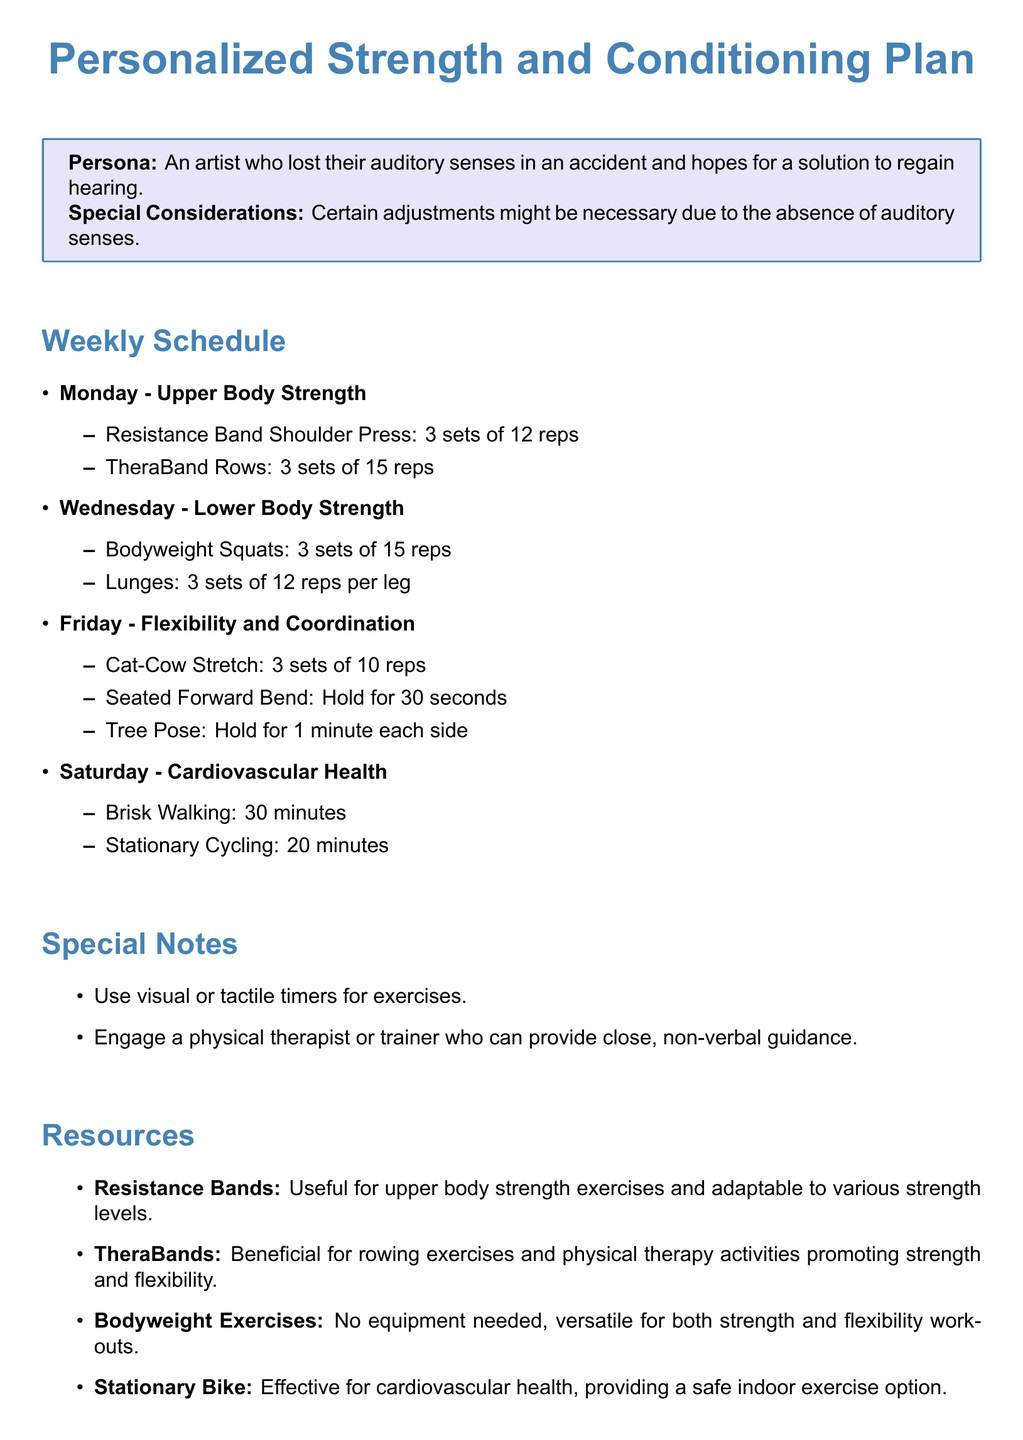what is the title of the plan? The title of the plan is clearly stated at the beginning of the document.
Answer: Personalized Strength and Conditioning Plan what day is designated for upper body strength training? The specific day for upper body strength training is indicated in the weekly schedule.
Answer: Monday how many reps are recommended for TheraBand Rows? The recommended reps for TheraBand Rows can be found in the exercise list under Upper Body Strength.
Answer: 15 reps what exercise is suggested for flexibility and coordination? The exercises for flexibility and coordination are listed specifically for that day's focus in the plan.
Answer: Cat-Cow Stretch how many minutes should one perform brisk walking on the designated day? The duration for brisk walking is specified in the Cardiovascular Health section of the weekly schedule.
Answer: 30 minutes what equipment is suggested for upper body strength exercises? The document mentions specific equipment suitable for upper body strength exercises, which is listed in the resources section.
Answer: Resistance Bands who should a visual artist engage for non-verbal guidance? The document includes a recommendation for support from a specific professional category related to physical training.
Answer: Physical therapist what type of bike is mentioned for cardiovascular health? The document references a specific type of bike useful for indoor cardiovascular exercise in the resources section.
Answer: Stationary Bike how many sets of Bodyweight Squats should be performed? The number of sets for Bodyweight Squats is detailed in the Lower Body Strength section.
Answer: 3 sets 